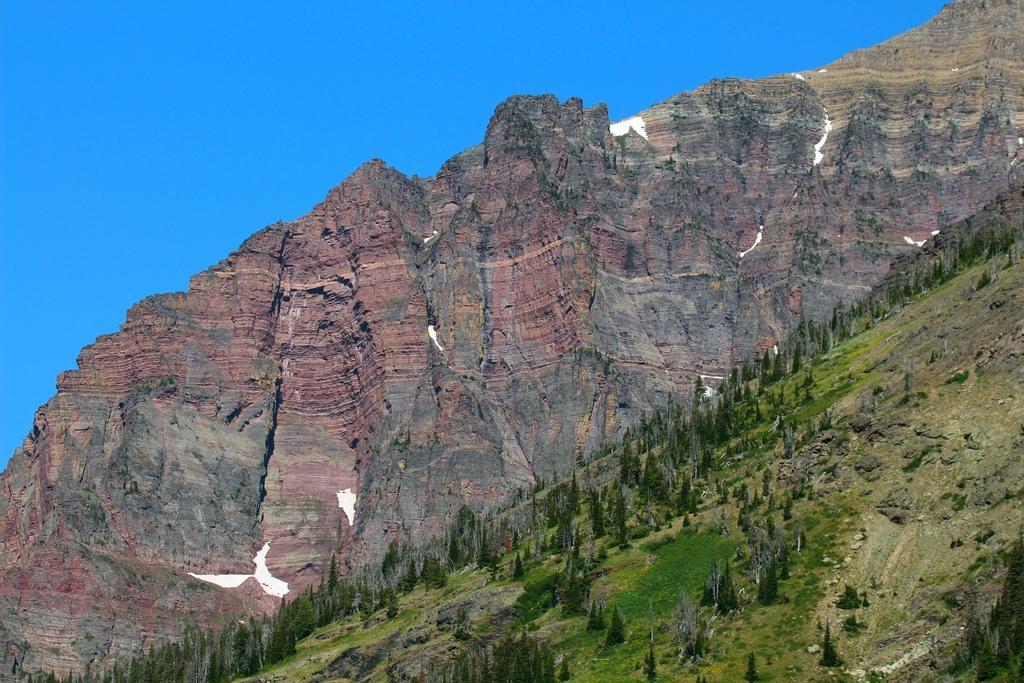Can you describe this image briefly? In this image I can see trees and mountains at the back. There is sky at the top. 